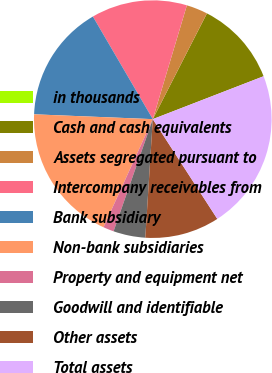Convert chart to OTSL. <chart><loc_0><loc_0><loc_500><loc_500><pie_chart><fcel>in thousands<fcel>Cash and cash equivalents<fcel>Assets segregated pursuant to<fcel>Intercompany receivables from<fcel>Bank subsidiary<fcel>Non-bank subsidiaries<fcel>Property and equipment net<fcel>Goodwill and identifiable<fcel>Other assets<fcel>Total assets<nl><fcel>0.0%<fcel>11.59%<fcel>2.9%<fcel>13.04%<fcel>15.94%<fcel>18.84%<fcel>1.45%<fcel>4.35%<fcel>10.14%<fcel>21.74%<nl></chart> 